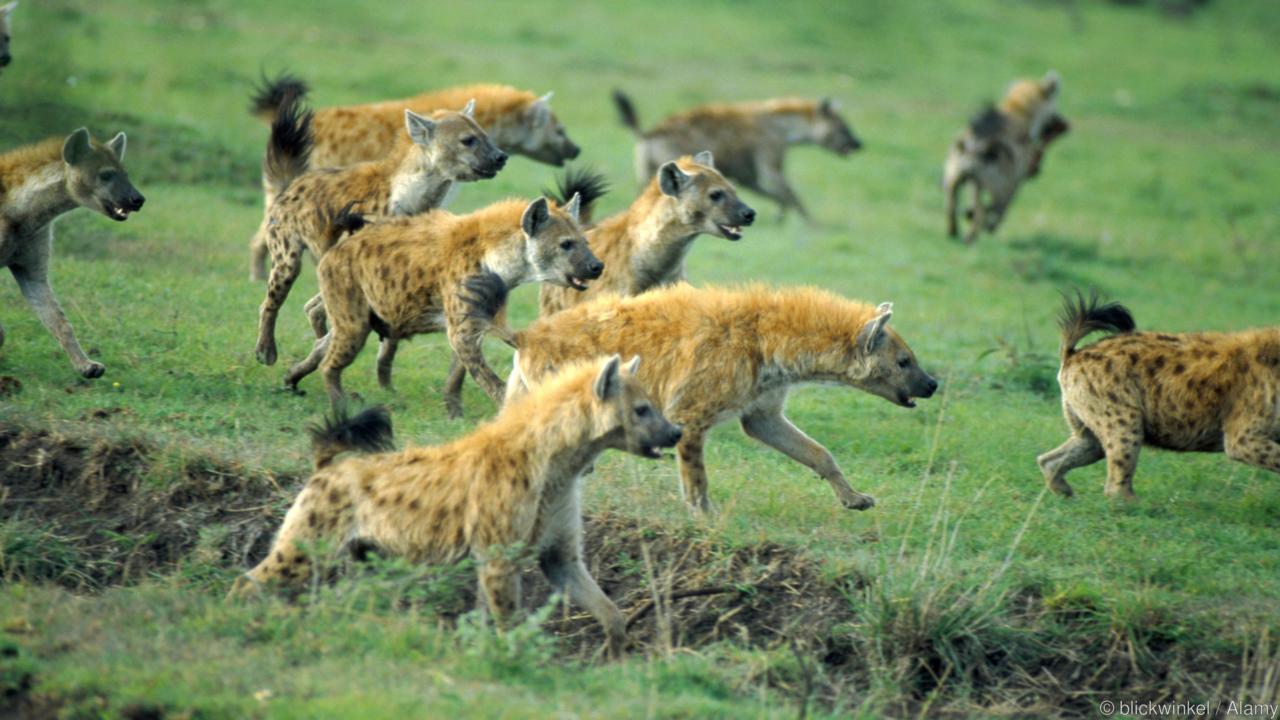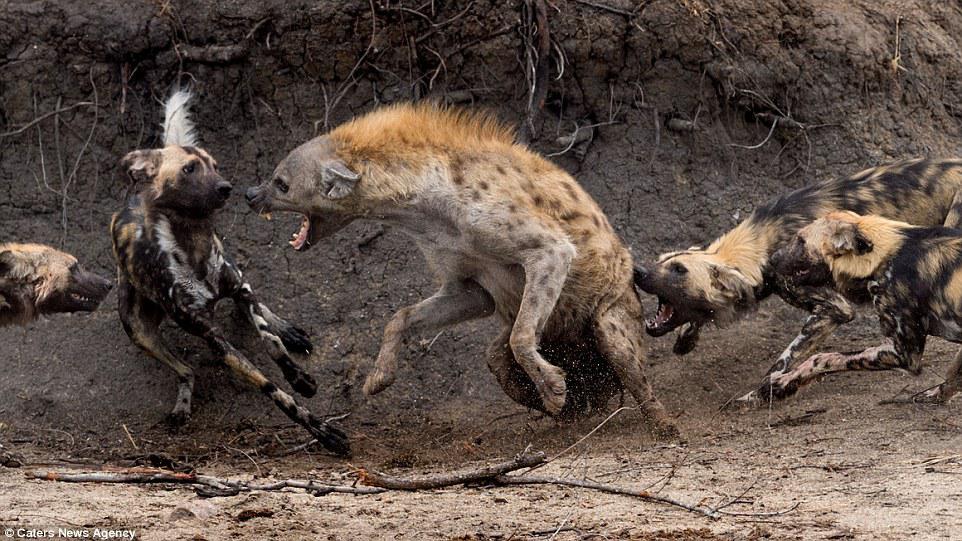The first image is the image on the left, the second image is the image on the right. Evaluate the accuracy of this statement regarding the images: "In one of the images there is a man surrounded by multiple hyenas.". Is it true? Answer yes or no. No. The first image is the image on the left, the second image is the image on the right. Analyze the images presented: Is the assertion "An image shows a man posed with three hyenas." valid? Answer yes or no. No. 